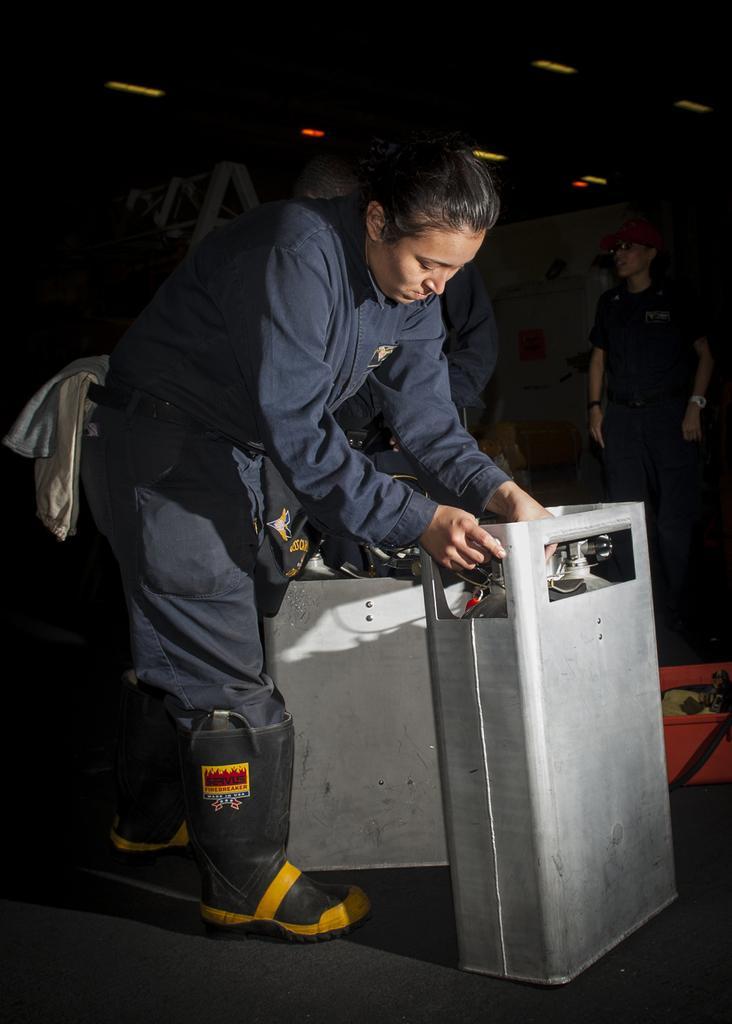Describe this image in one or two sentences. In this image on the foreground there is a lady wearing blue suit. She is holding a machine. In the background there are few other people. On the ceiling there are lights. 